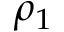<formula> <loc_0><loc_0><loc_500><loc_500>\rho _ { 1 }</formula> 